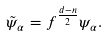<formula> <loc_0><loc_0><loc_500><loc_500>\tilde { \psi } _ { \alpha } = f ^ { \frac { d - n } { 2 } } \psi _ { \alpha } .</formula> 